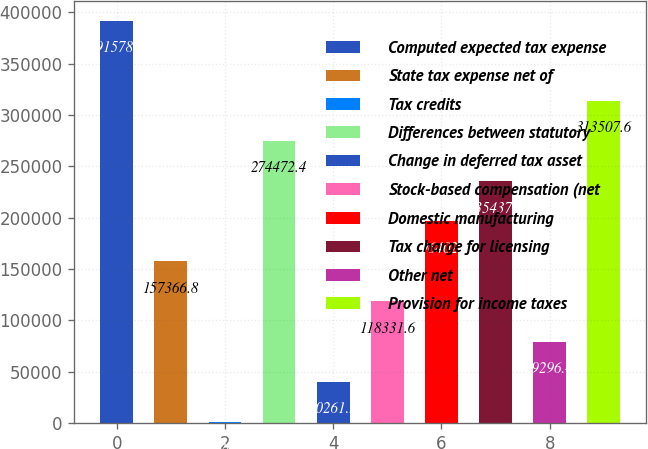Convert chart. <chart><loc_0><loc_0><loc_500><loc_500><bar_chart><fcel>Computed expected tax expense<fcel>State tax expense net of<fcel>Tax credits<fcel>Differences between statutory<fcel>Change in deferred tax asset<fcel>Stock-based compensation (net<fcel>Domestic manufacturing<fcel>Tax charge for licensing<fcel>Other net<fcel>Provision for income taxes<nl><fcel>391578<fcel>157367<fcel>1226<fcel>274472<fcel>40261.2<fcel>118332<fcel>196402<fcel>235437<fcel>79296.4<fcel>313508<nl></chart> 